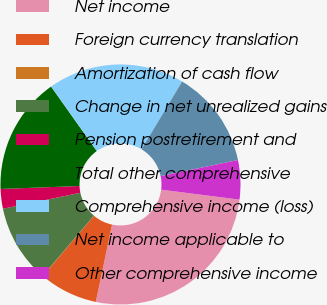Convert chart to OTSL. <chart><loc_0><loc_0><loc_500><loc_500><pie_chart><fcel>Net income<fcel>Foreign currency translation<fcel>Amortization of cash flow<fcel>Change in net unrealized gains<fcel>Pension postretirement and<fcel>Total other comprehensive<fcel>Comprehensive income (loss)<fcel>Net income applicable to<fcel>Other comprehensive income<nl><fcel>26.28%<fcel>7.9%<fcel>0.03%<fcel>10.53%<fcel>2.65%<fcel>15.78%<fcel>18.4%<fcel>13.15%<fcel>5.28%<nl></chart> 